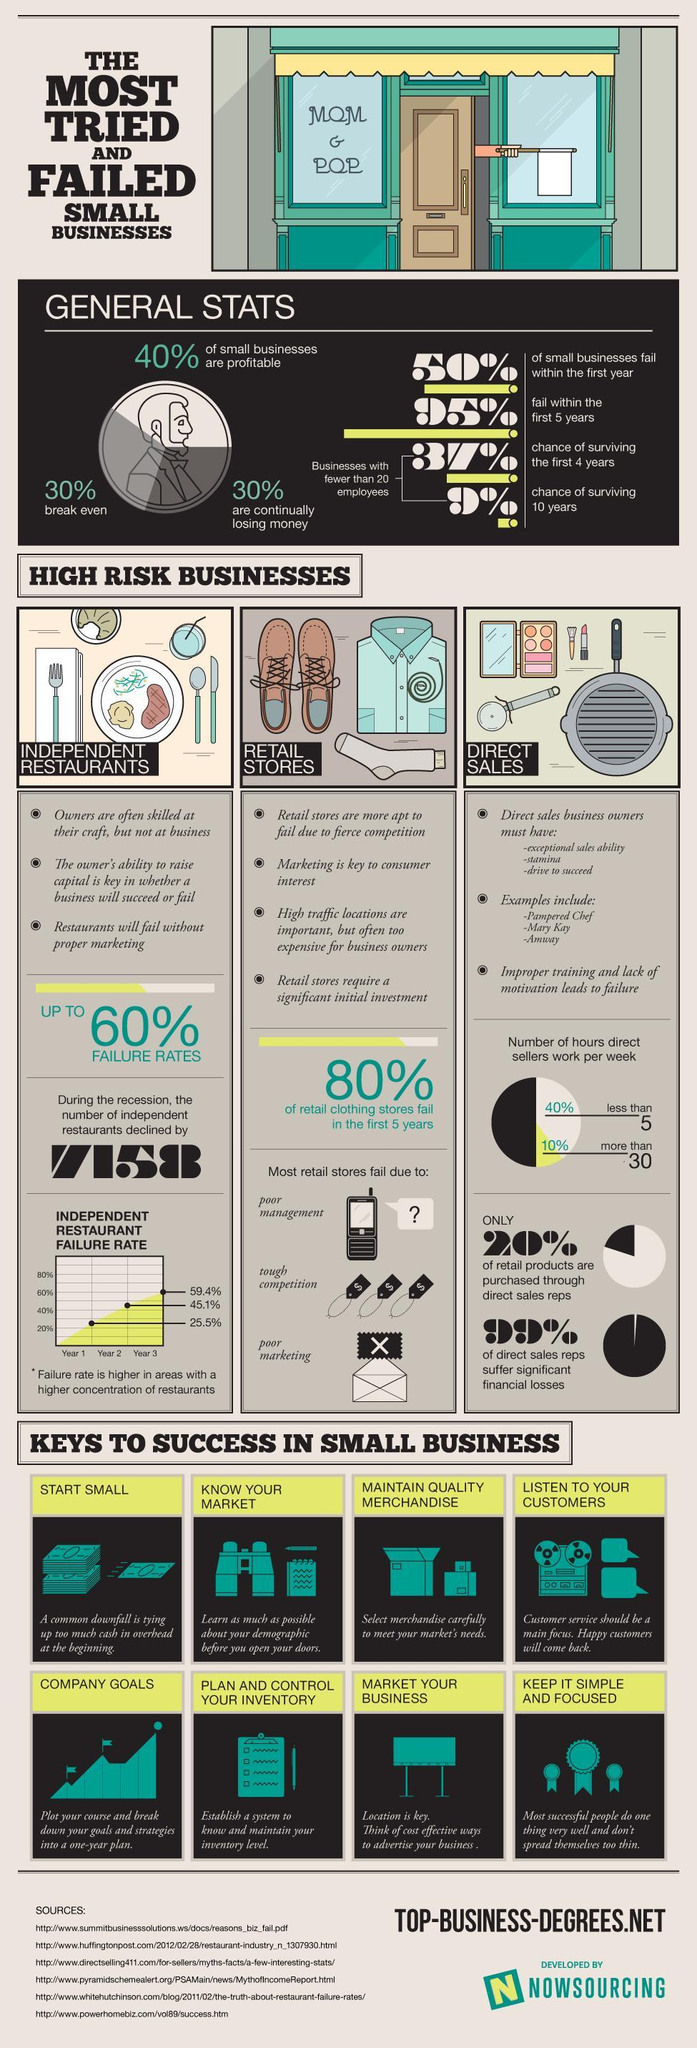How many reasons contribute to the failure of retails stores?
Answer the question with a short phrase. 3 How many tips are given in the list of keys to success in small business? 8 